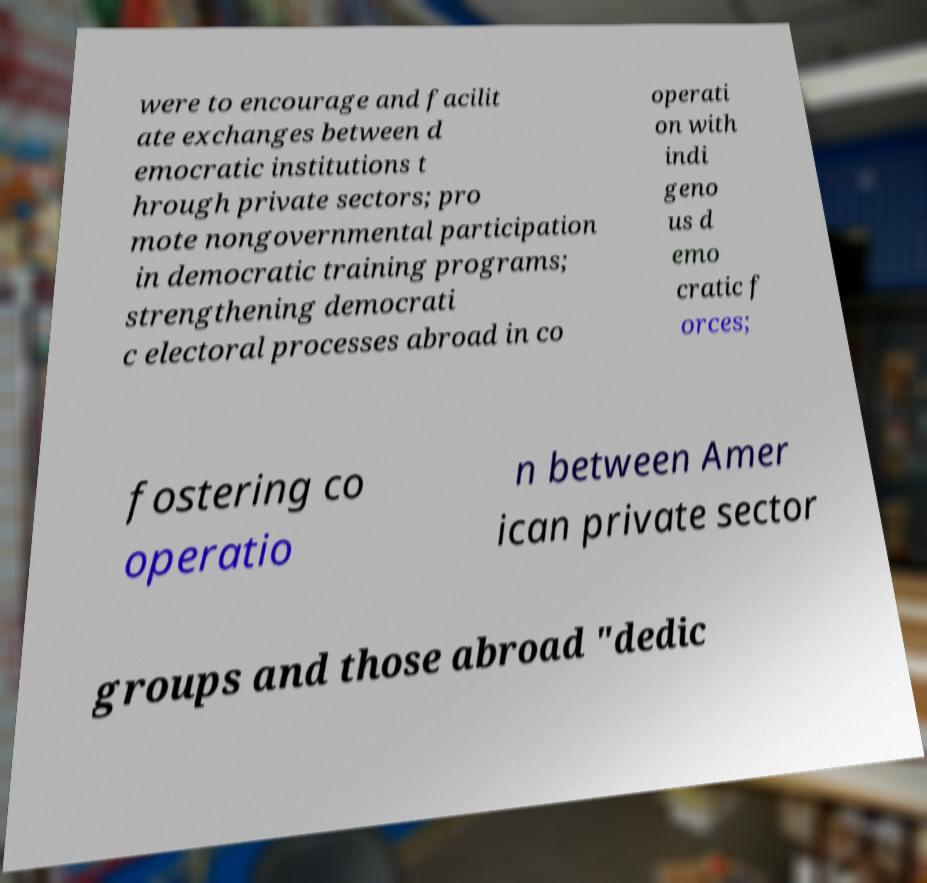Could you extract and type out the text from this image? were to encourage and facilit ate exchanges between d emocratic institutions t hrough private sectors; pro mote nongovernmental participation in democratic training programs; strengthening democrati c electoral processes abroad in co operati on with indi geno us d emo cratic f orces; fostering co operatio n between Amer ican private sector groups and those abroad "dedic 